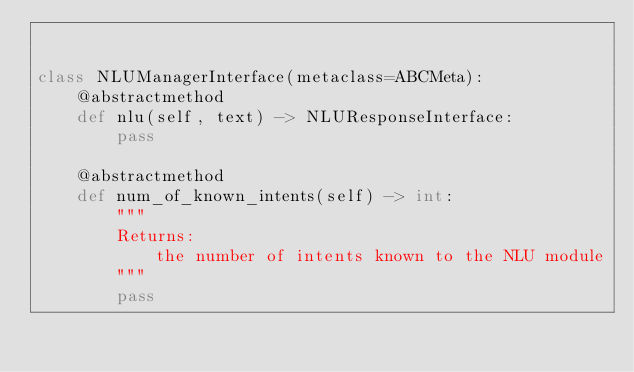<code> <loc_0><loc_0><loc_500><loc_500><_Python_>

class NLUManagerInterface(metaclass=ABCMeta):
    @abstractmethod
    def nlu(self, text) -> NLUResponseInterface:
        pass

    @abstractmethod
    def num_of_known_intents(self) -> int:
        """
        Returns:
            the number of intents known to the NLU module
        """
        pass
</code> 